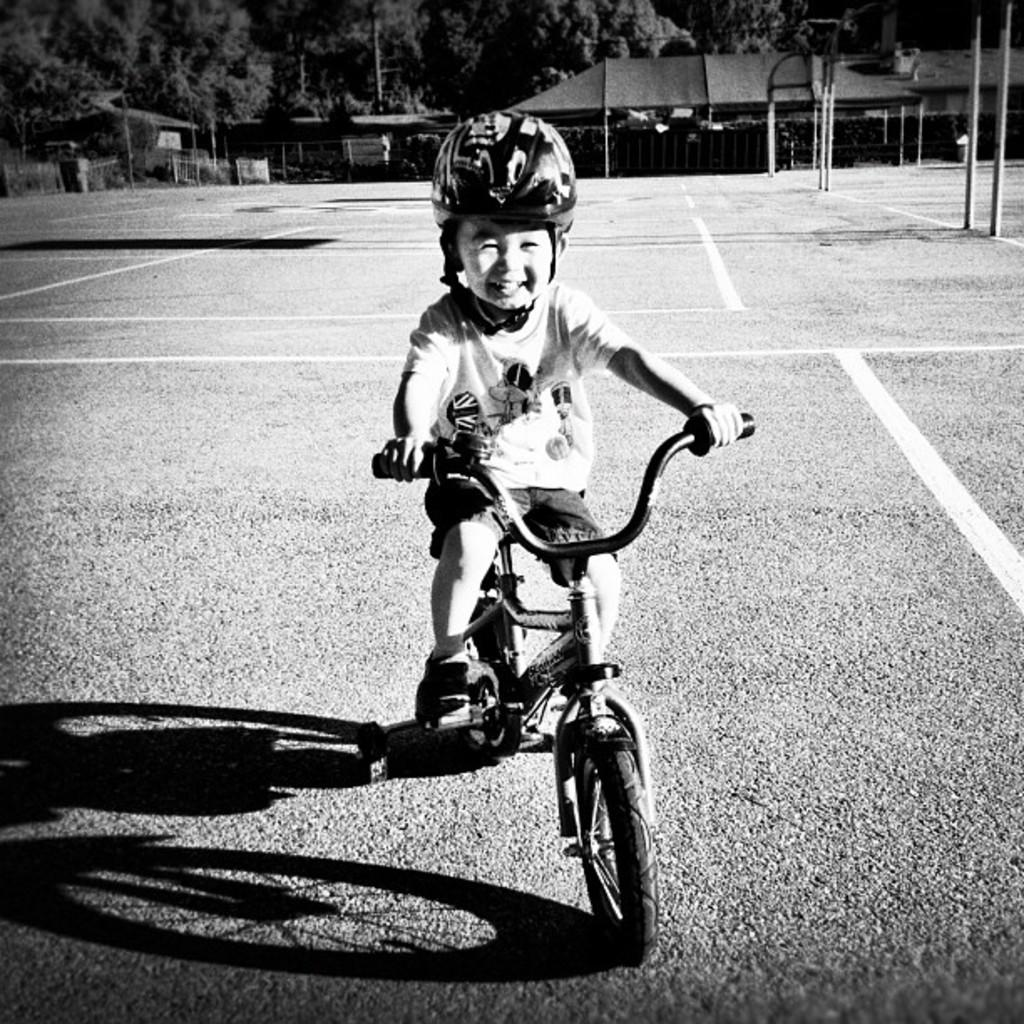What is the main subject of the picture? The main subject of the picture is a kid. What is the kid doing in the picture? The kid is sitting on a bicycle and holding it. What can be seen in the background of the image? There are trees and a shed in the background of the image. Is there any indication of a road in the image? Yes, there is a road visible in the image. What type of oil can be seen dripping from the bicycle in the image? There is no oil visible in the image, and the bicycle is not shown to be dripping any substance. What amusement park can be seen in the background of the image? There is no amusement park present in the image; it features a road, trees, and a shed in the background. 